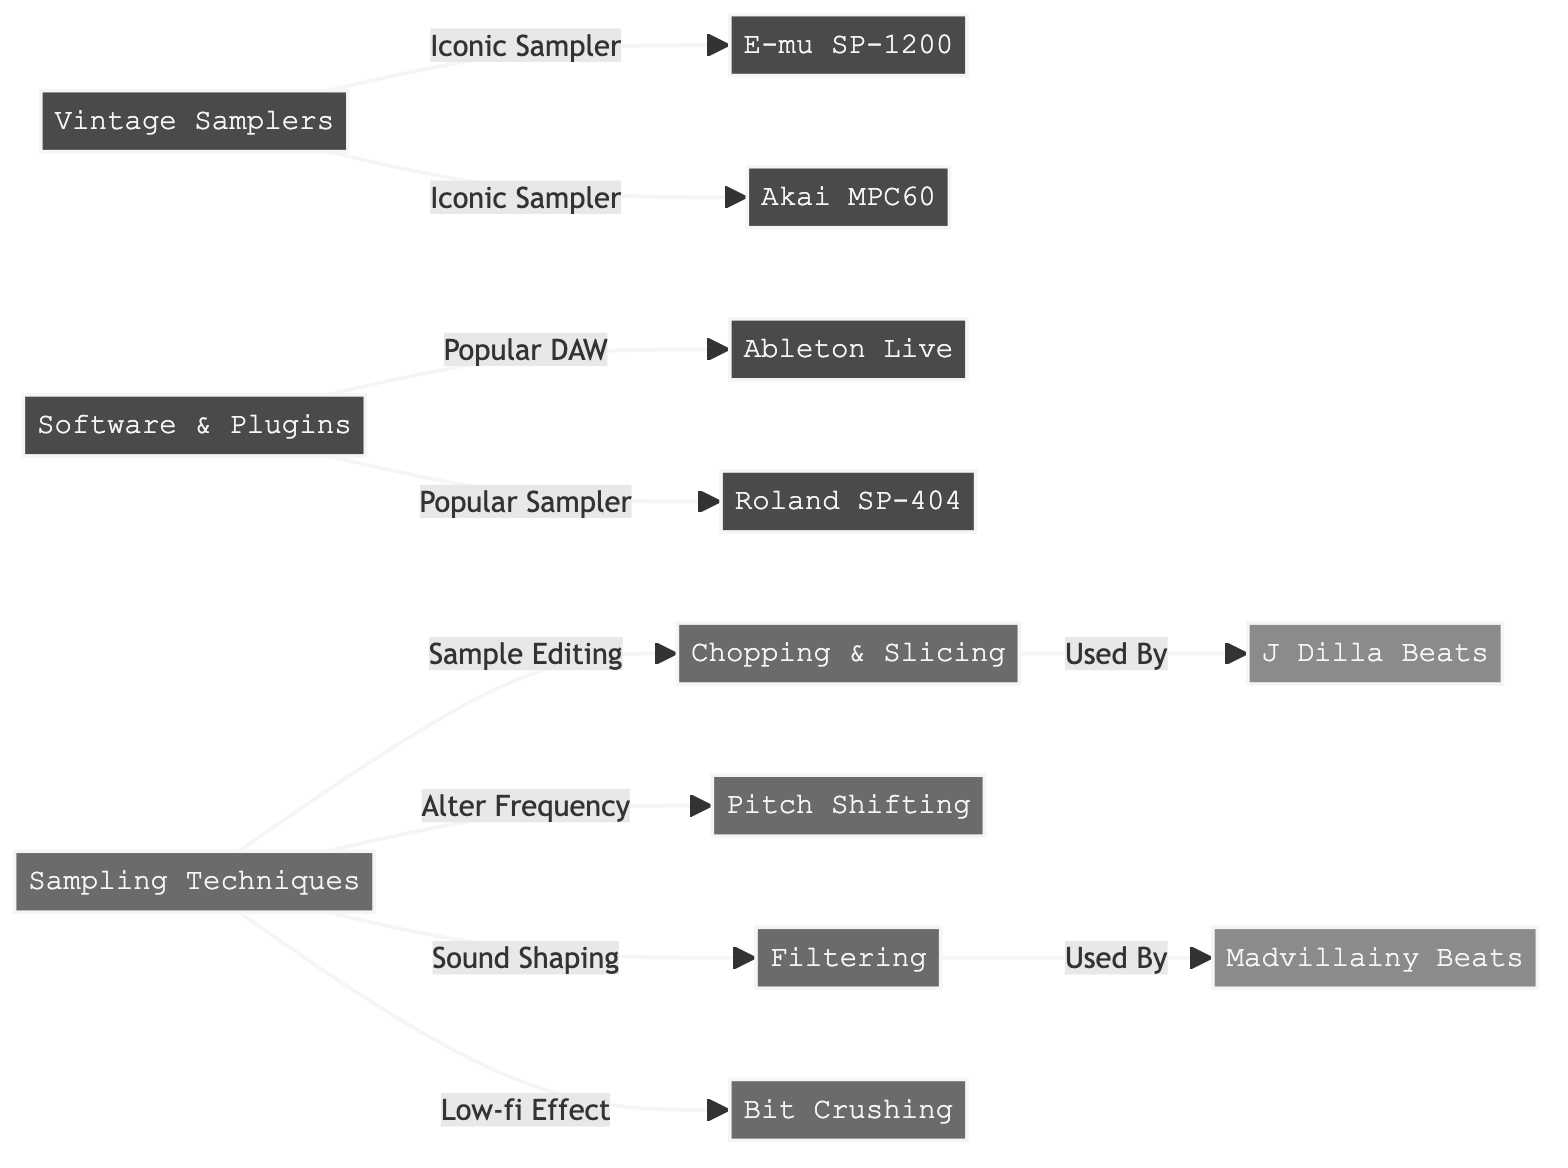What's the main category for the samplers used in the diagram? The main category for the samplers is "Vintage Samplers," which is the parent node directly connected to specific iconic samplers like the E-mu SP-1200 and Akai MPC60.
Answer: Vintage Samplers How many sampling techniques are listed in the diagram? The diagram lists four sampling techniques: Chopping & Slicing, Pitch Shifting, Filtering, and Bit Crushing. Counting these gives a total of four techniques.
Answer: 4 Which iconic sampler is associated with the "Used By" label related to J Dilla? The chopping technique is associated with the "Used By" label indicating its use by J Dilla beats. This relationship shows the specific technique linked to that beat style.
Answer: Chopping & Slicing What is the purpose of the Filtering technique according to the diagram? The Filtering technique is described as "Sound Shaping," meaning it is used to modify and affect the sound quality and character of the samples.
Answer: Sound Shaping Which software is categorized as a popular DAW in the diagram? Ableton Live is directly linked under the "Software & Plugins" node, denoting it as a popular digital audio workstation (DAW).
Answer: Ableton Live Which iconic beats are associated with the Filtering technique? The Filtering technique is noted to be used in Madvillainy Beats, which is linked via the relationship shown in the diagram, demonstrating its application in that specific iconic beat.
Answer: Madvillainy Beats What unique effect does the Bit Crushing technique provide? The Bit Crushing technique is labeled as a "Low-fi Effect," indicating its primary function in creating a specific sound texture characteristic of lo-fi hip-hop music.
Answer: Low-fi Effect How many equipment types are displayed in the diagram? The diagram shows five equipment types, including various vintage samplers and a DAW, which are all categorized under the "Equipment" section.
Answer: 5 